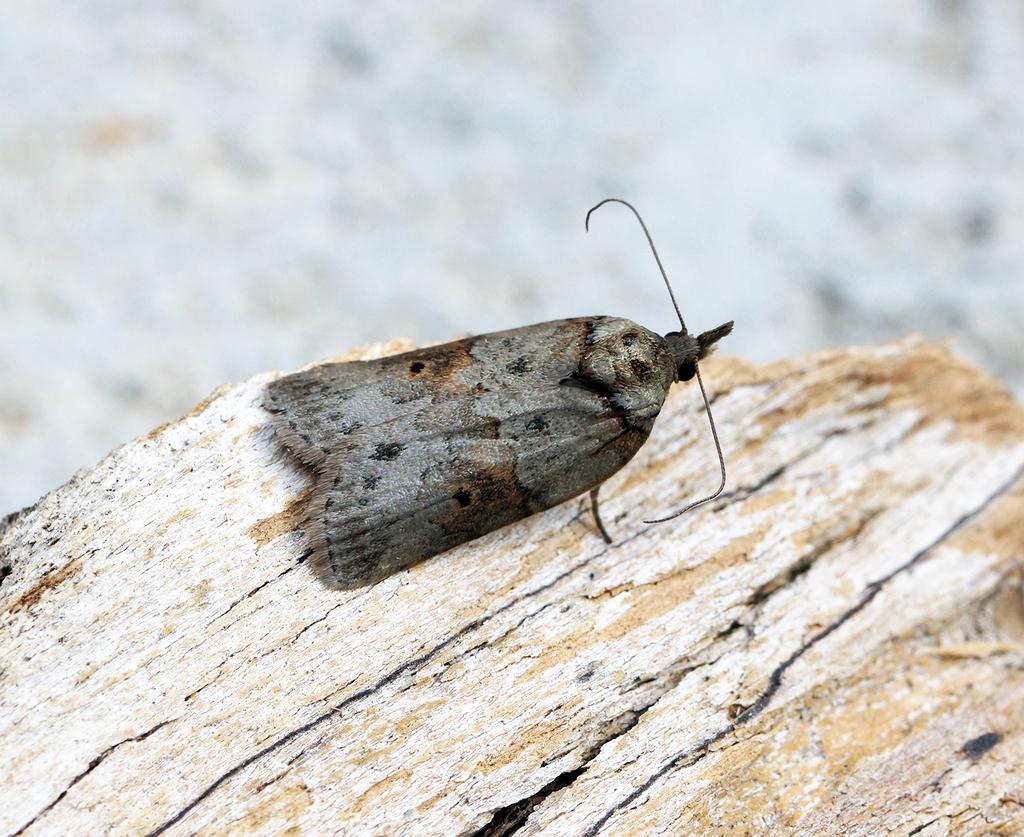How would you summarize this image in a sentence or two? In this image there is one insect is on a wooden object as we can see in bottom of this image. 